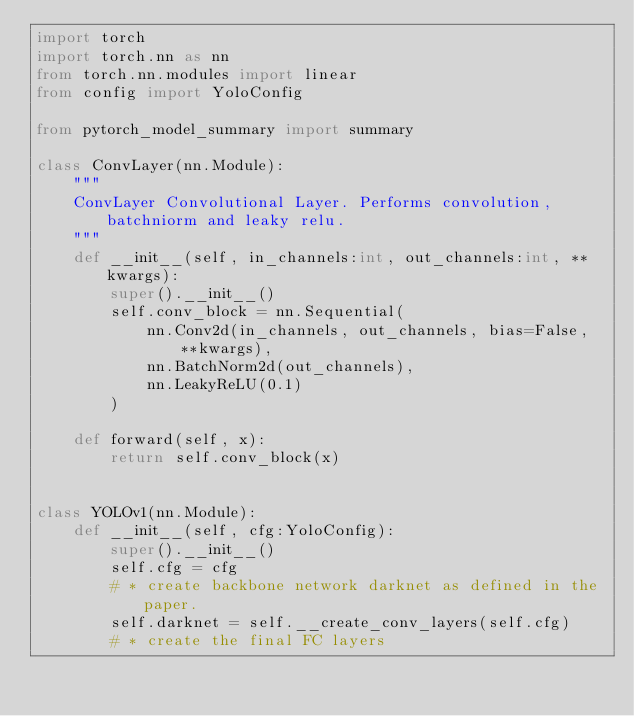Convert code to text. <code><loc_0><loc_0><loc_500><loc_500><_Python_>import torch
import torch.nn as nn
from torch.nn.modules import linear
from config import YoloConfig

from pytorch_model_summary import summary

class ConvLayer(nn.Module):
    """
    ConvLayer Convolutional Layer. Performs convolution, batchniorm and leaky relu.
    """
    def __init__(self, in_channels:int, out_channels:int, **kwargs):
        super().__init__()
        self.conv_block = nn.Sequential(
            nn.Conv2d(in_channels, out_channels, bias=False, **kwargs),
            nn.BatchNorm2d(out_channels),
            nn.LeakyReLU(0.1)
        )

    def forward(self, x):
        return self.conv_block(x)


class YOLOv1(nn.Module):
    def __init__(self, cfg:YoloConfig):
        super().__init__()
        self.cfg = cfg
        # * create backbone network darknet as defined in the paper.
        self.darknet = self.__create_conv_layers(self.cfg)
        # * create the final FC layers</code> 